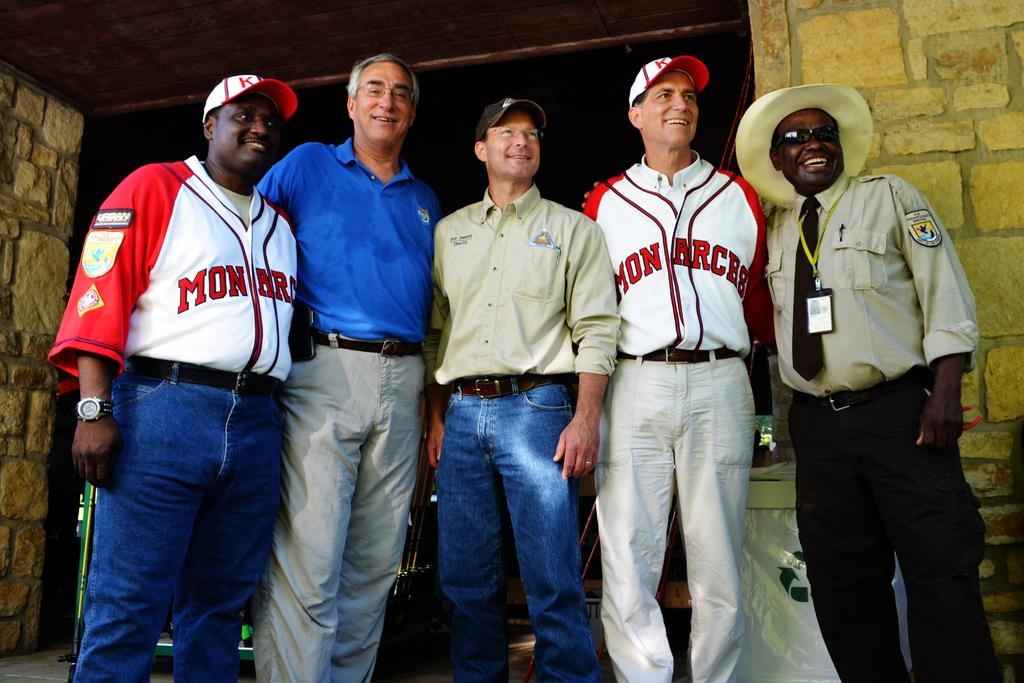<image>
Give a short and clear explanation of the subsequent image. a man with a Monarchs shirt on is with other people 